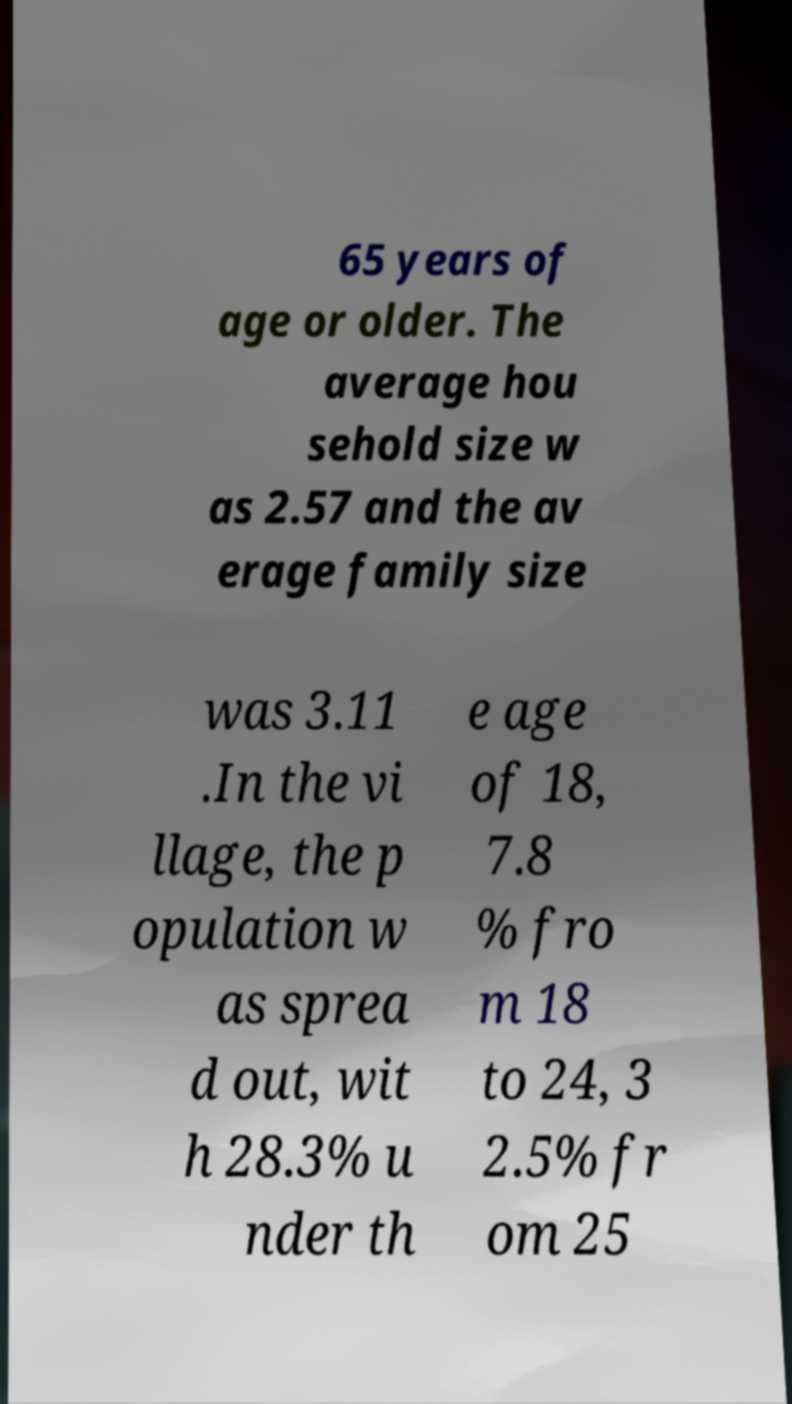There's text embedded in this image that I need extracted. Can you transcribe it verbatim? 65 years of age or older. The average hou sehold size w as 2.57 and the av erage family size was 3.11 .In the vi llage, the p opulation w as sprea d out, wit h 28.3% u nder th e age of 18, 7.8 % fro m 18 to 24, 3 2.5% fr om 25 